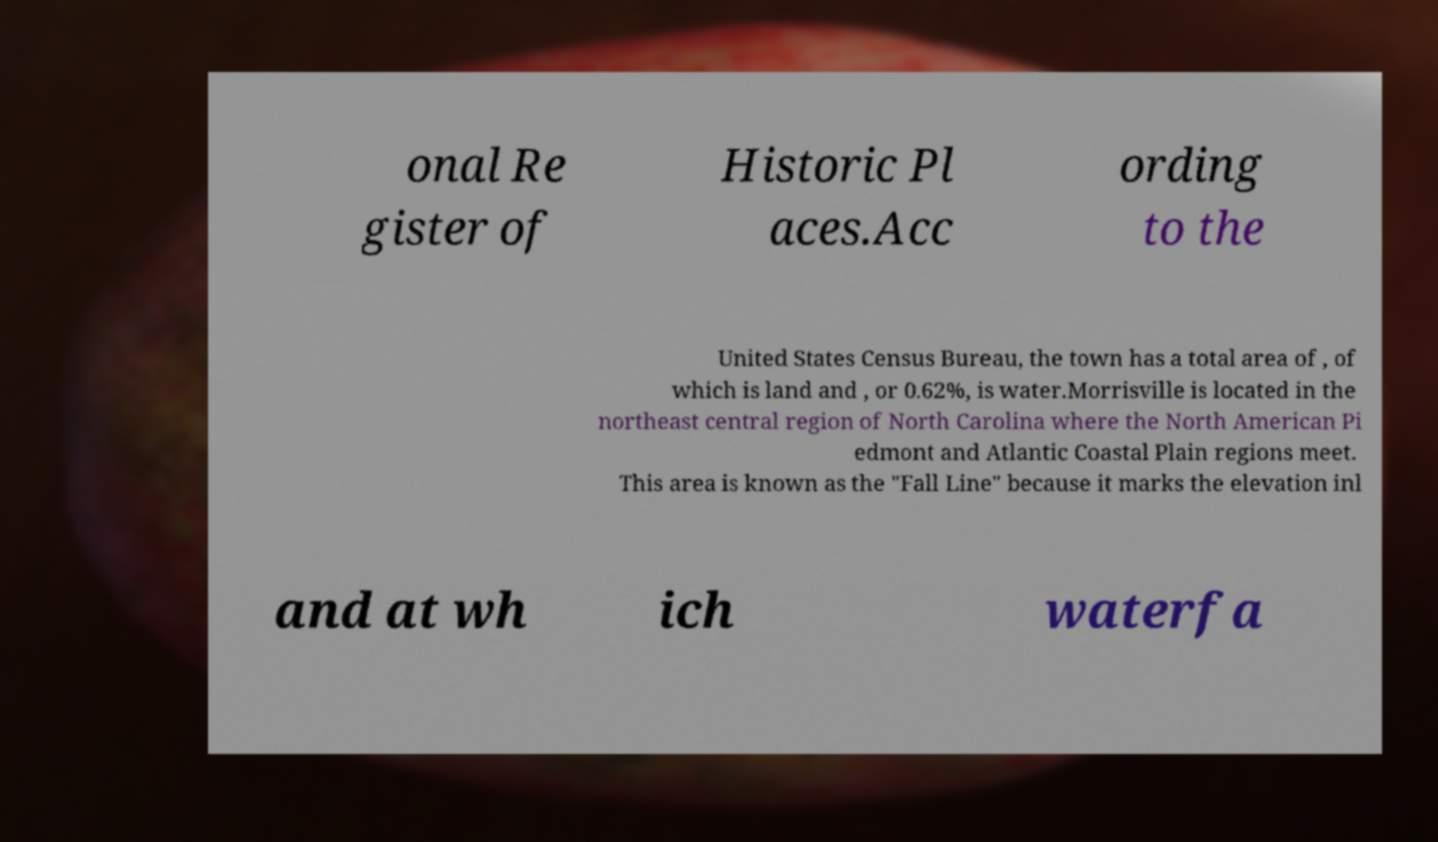For documentation purposes, I need the text within this image transcribed. Could you provide that? onal Re gister of Historic Pl aces.Acc ording to the United States Census Bureau, the town has a total area of , of which is land and , or 0.62%, is water.Morrisville is located in the northeast central region of North Carolina where the North American Pi edmont and Atlantic Coastal Plain regions meet. This area is known as the "Fall Line" because it marks the elevation inl and at wh ich waterfa 